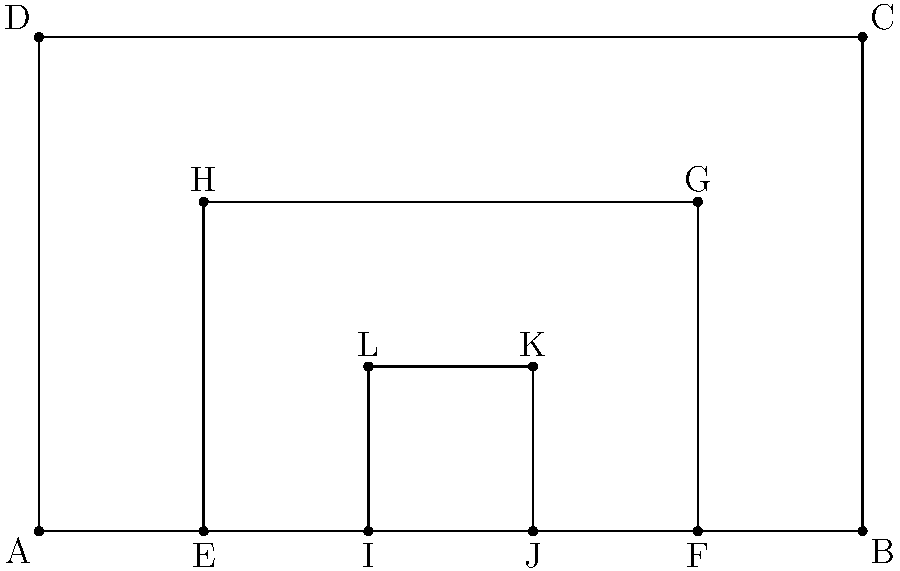In the coordinate system shown, a Renaissance church facade is represented by rectangles ABCD (main facade), EFGH (portal), and IJKL (door). Given that the width of the main facade is 10 units and its height is 6 units, calculate the ratio of the area of the portal (EFGH) to the area of the main facade (ABCD). How does this ratio relate to the concept of "harmonic proportions" often used in Renaissance architecture? To solve this problem, we'll follow these steps:

1) First, let's calculate the areas of the main facade and the portal:

   Area of main facade (ABCD): $10 \times 6 = 60$ square units

   For the portal (EFGH):
   Width = $8 - 2 = 6$ units
   Height = $4$ units
   Area of portal = $6 \times 4 = 24$ square units

2) Now, let's calculate the ratio:

   Ratio = Area of portal : Area of main facade
         = $24 : 60$
         = $2 : 5$ or $0.4 : 1$

3) This ratio, $2:5$ or $0.4$, is significant in Renaissance architecture. It closely approximates the "Golden Ratio" ($\approx 0.618$), which was considered a "divine proportion" and often used in Renaissance designs.

4) In terms of harmonic proportions, this ratio represents a balance between the portal and the overall facade. The portal is large enough to be prominent, yet not so large as to dominate the facade.

5) Furthermore, the ratio of the portal's width to the facade's width ($6:10$ or $3:5$) and the ratio of the portal's height to the facade's height ($4:6$ or $2:3$) are both simple ratios, reflecting the Renaissance preference for rational, harmonious proportions.

6) The nested rectangles (main facade, portal, door) demonstrate the concept of "hierarchical proportion," another key principle in Renaissance architecture, where similar shapes are repeated at different scales.
Answer: The ratio is $2:5$ (or $0.4:1$), approximating the Golden Ratio and exemplifying Renaissance harmonic proportions through rational ratios and hierarchical scaling. 